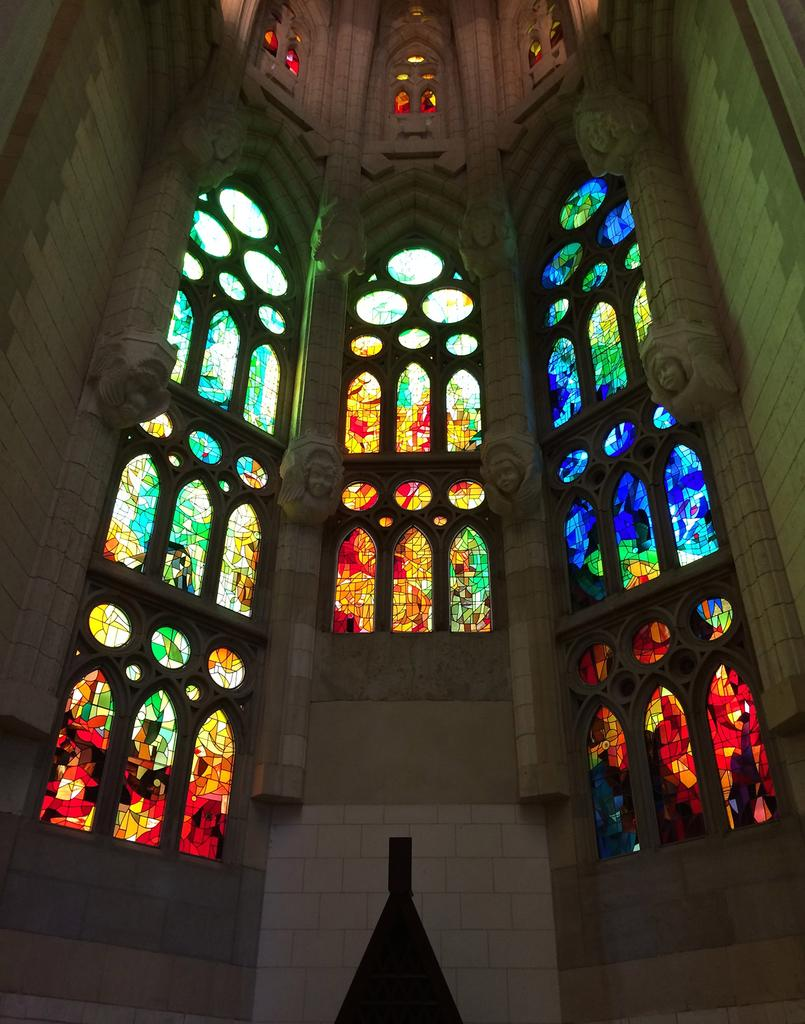What type of windows are depicted in the image? There are windows with stained glass in the image. What color is the wall in the image? There is a wall in cream color in the image. What type of lamp is hanging from the ceiling in the image? There is no lamp present in the image; it only features windows with stained glass and a cream-colored wall. 